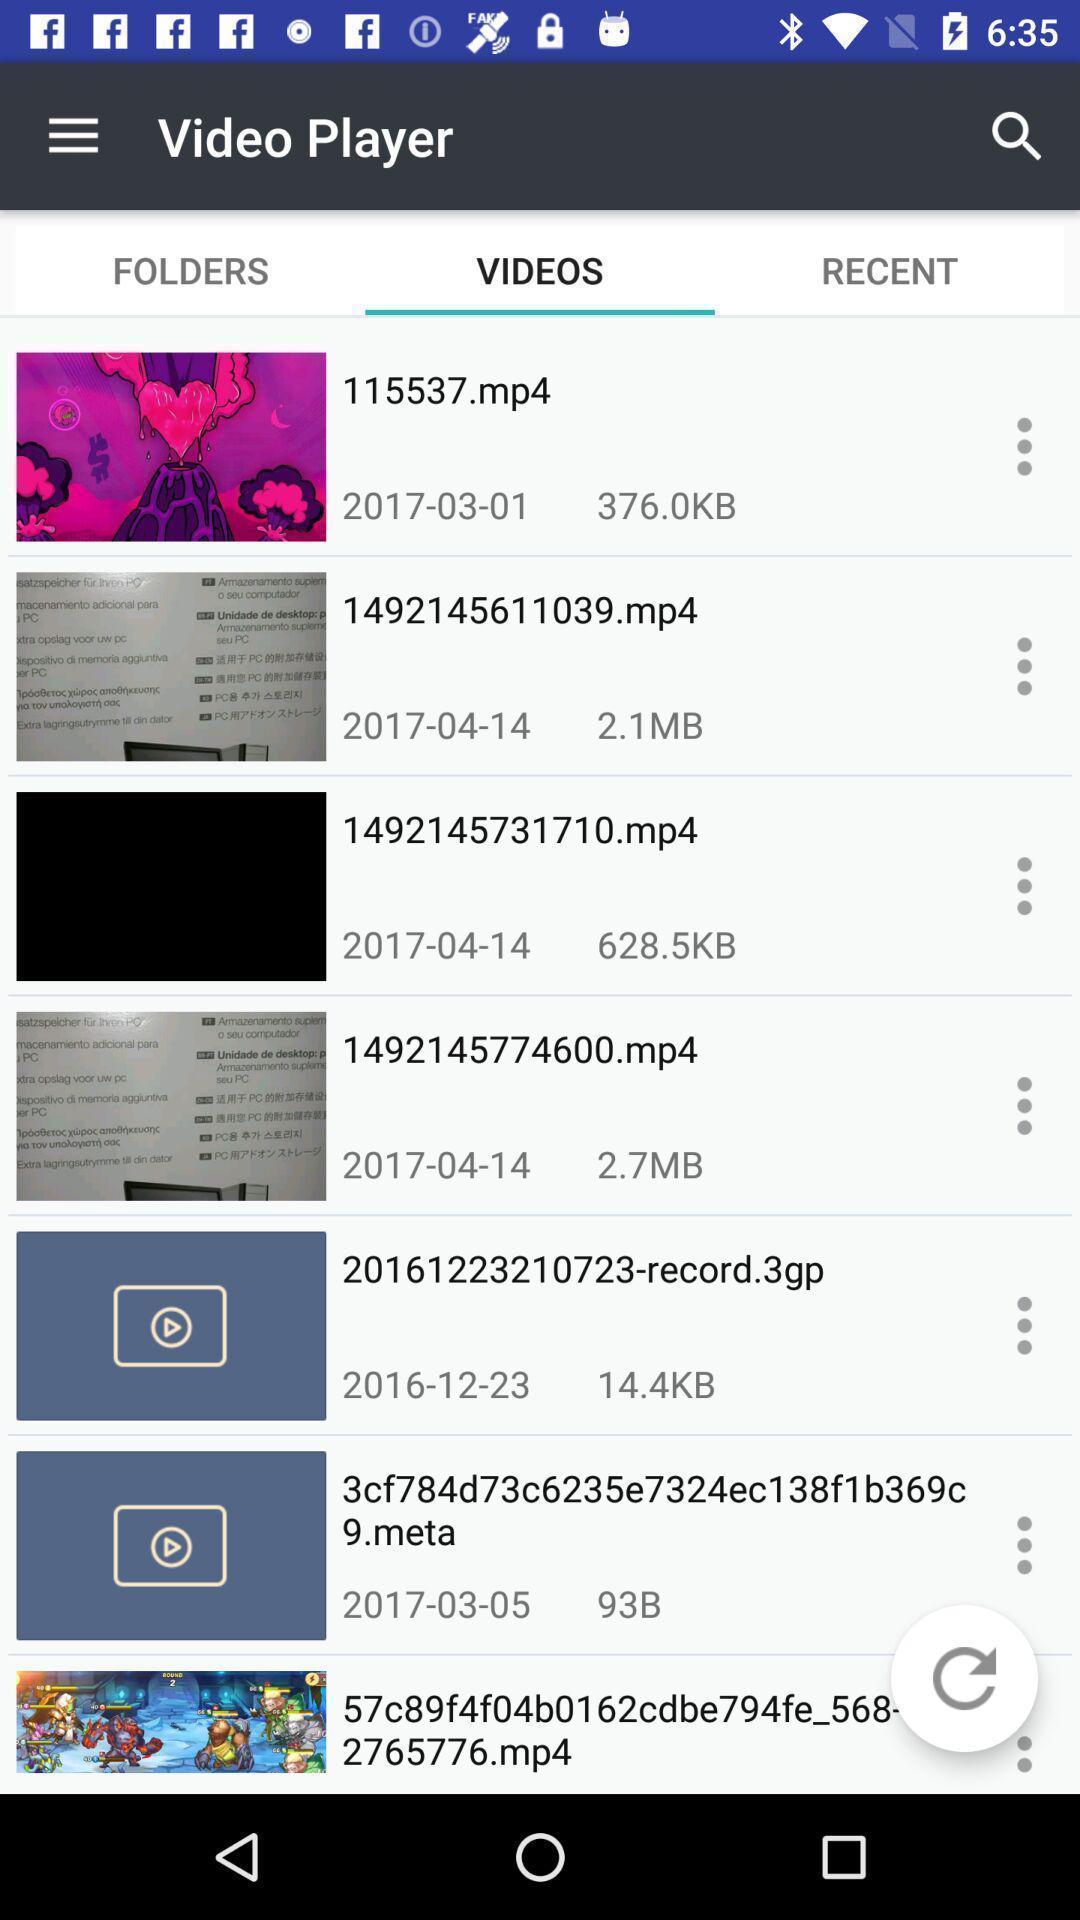Summarize the main components in this picture. Page displaying various videos. 